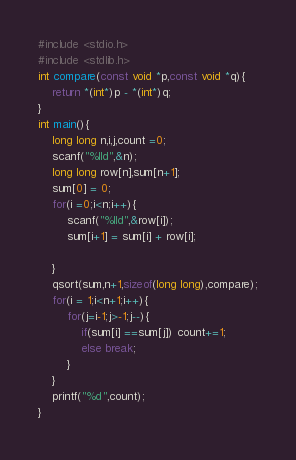Convert code to text. <code><loc_0><loc_0><loc_500><loc_500><_C_>#include <stdio.h>
#include <stdlib.h>
int compare(const void *p,const void *q){
	return *(int*)p - *(int*)q;
}
int main(){
	long long n,i,j,count =0;
	scanf("%lld",&n);
	long long row[n],sum[n+1];
	sum[0] = 0;
	for(i =0;i<n;i++){
		scanf("%lld",&row[i]);
		sum[i+1] = sum[i] + row[i];
		
	}
	qsort(sum,n+1,sizeof(long long),compare);
	for(i = 1;i<n+1;i++){
		for(j=i-1;j>-1;j--){
			if(sum[i] ==sum[j]) count+=1;
			else break;
		}
	}
	printf("%d",count);
}</code> 